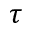Convert formula to latex. <formula><loc_0><loc_0><loc_500><loc_500>\tau</formula> 